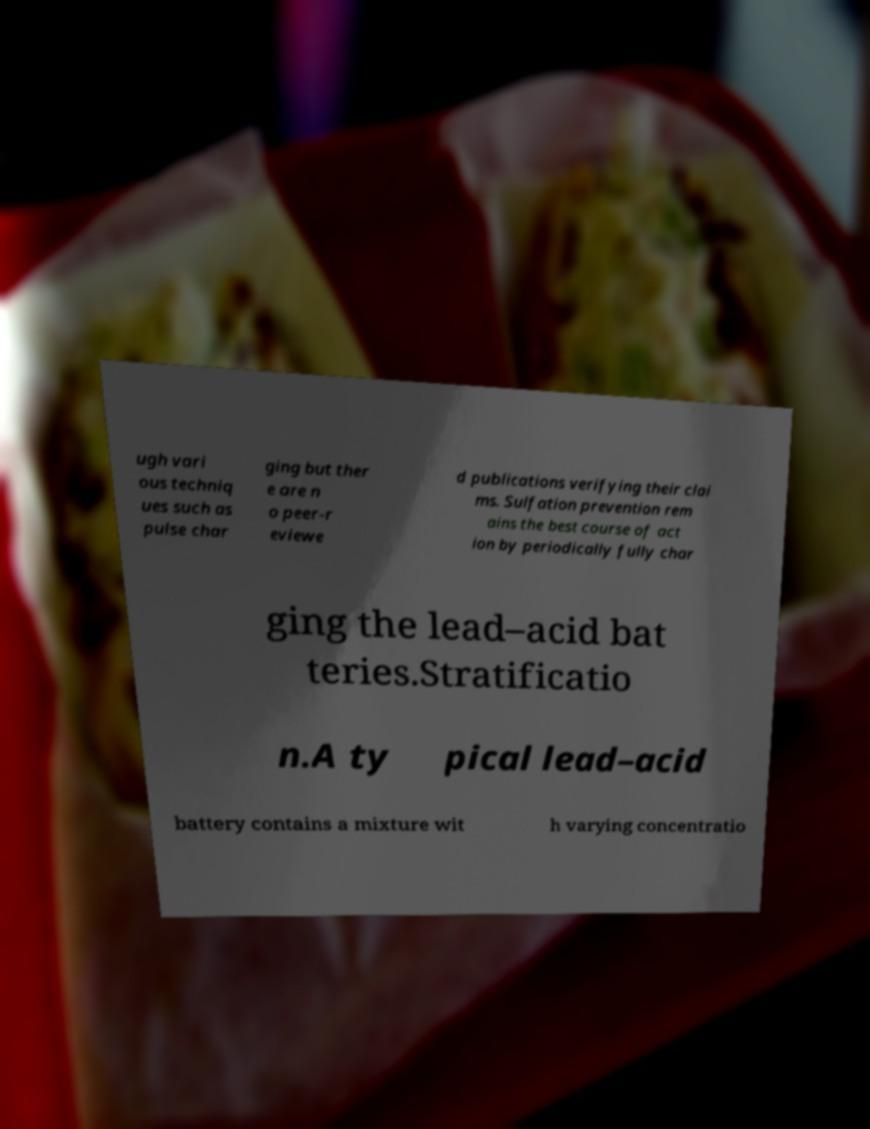What messages or text are displayed in this image? I need them in a readable, typed format. ugh vari ous techniq ues such as pulse char ging but ther e are n o peer-r eviewe d publications verifying their clai ms. Sulfation prevention rem ains the best course of act ion by periodically fully char ging the lead–acid bat teries.Stratificatio n.A ty pical lead–acid battery contains a mixture wit h varying concentratio 